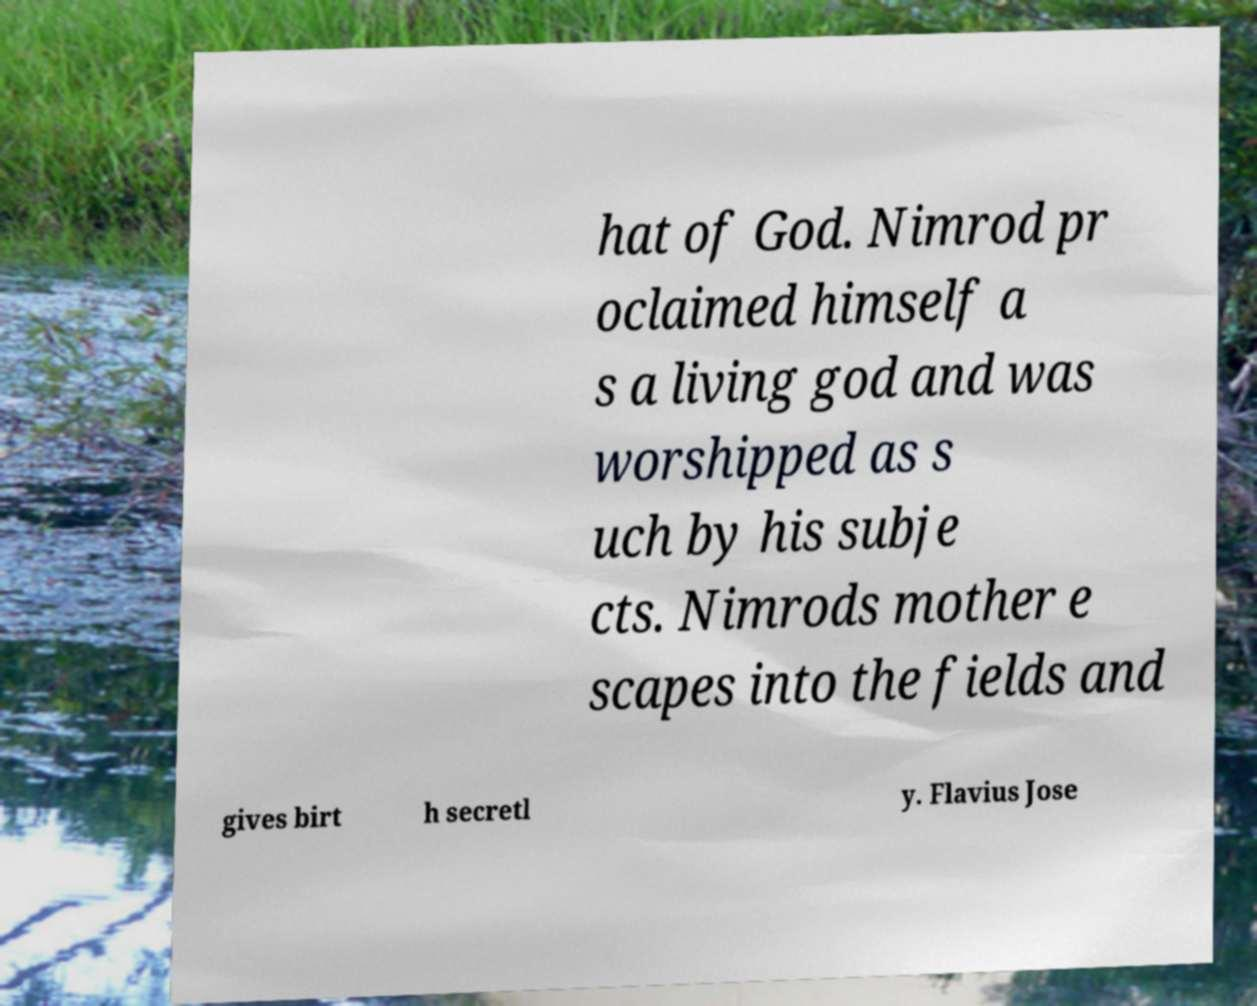For documentation purposes, I need the text within this image transcribed. Could you provide that? hat of God. Nimrod pr oclaimed himself a s a living god and was worshipped as s uch by his subje cts. Nimrods mother e scapes into the fields and gives birt h secretl y. Flavius Jose 